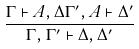<formula> <loc_0><loc_0><loc_500><loc_500>\frac { \Gamma \vdash A , \Delta \Gamma ^ { \prime } , A \vdash \Delta ^ { \prime } } { \Gamma , \Gamma ^ { \prime } \vdash \Delta , \Delta ^ { \prime } }</formula> 